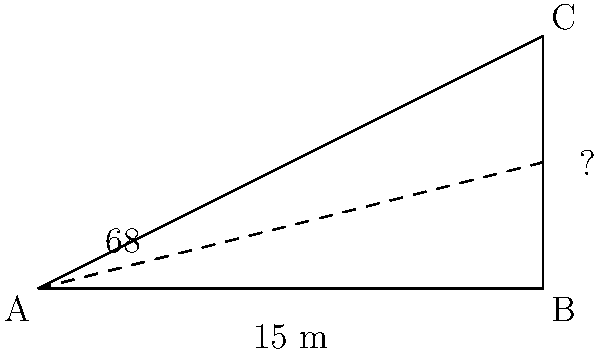A building casts a shadow 15 meters long when the angle of elevation of the sun is 68°. Using trigonometry, calculate the height of the building to the nearest tenth of a meter. Let's approach this step-by-step using trigonometric ratios:

1) We can represent this scenario as a right-angled triangle, where:
   - The shadow length is the base of the triangle (adjacent to the angle)
   - The building height is the opposite side
   - The angle of elevation is the angle between the base and the hypotenuse

2) We know:
   - Adjacent side (shadow length) = 15 meters
   - Angle of elevation = 68°

3) We need to find the opposite side (building height)

4) The trigonometric ratio that relates the opposite side to the adjacent side is tangent:

   $\tan(\theta) = \frac{\text{opposite}}{\text{adjacent}}$

5) Substituting our known values:

   $\tan(68°) = \frac{\text{height}}{15}$

6) To solve for height, we multiply both sides by 15:

   $15 \times \tan(68°) = \text{height}$

7) Using a calculator:

   $15 \times \tan(68°) \approx 15 \times 2.4751 \approx 37.1265$

8) Rounding to the nearest tenth:

   Height ≈ 37.1 meters
Answer: 37.1 meters 